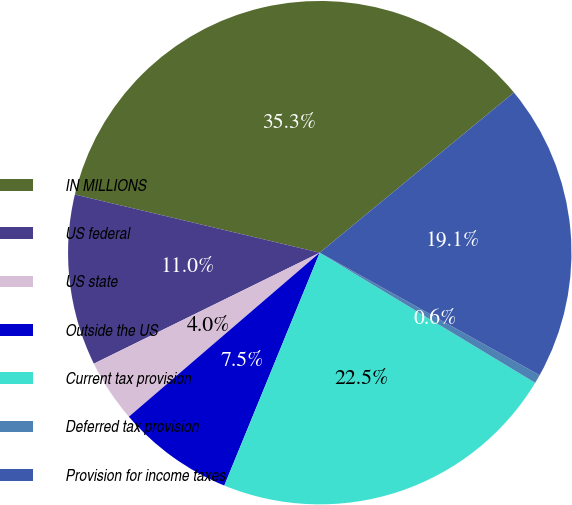<chart> <loc_0><loc_0><loc_500><loc_500><pie_chart><fcel>IN MILLIONS<fcel>US federal<fcel>US state<fcel>Outside the US<fcel>Current tax provision<fcel>Deferred tax provision<fcel>Provision for income taxes<nl><fcel>35.31%<fcel>10.98%<fcel>4.03%<fcel>7.51%<fcel>22.54%<fcel>0.56%<fcel>19.07%<nl></chart> 